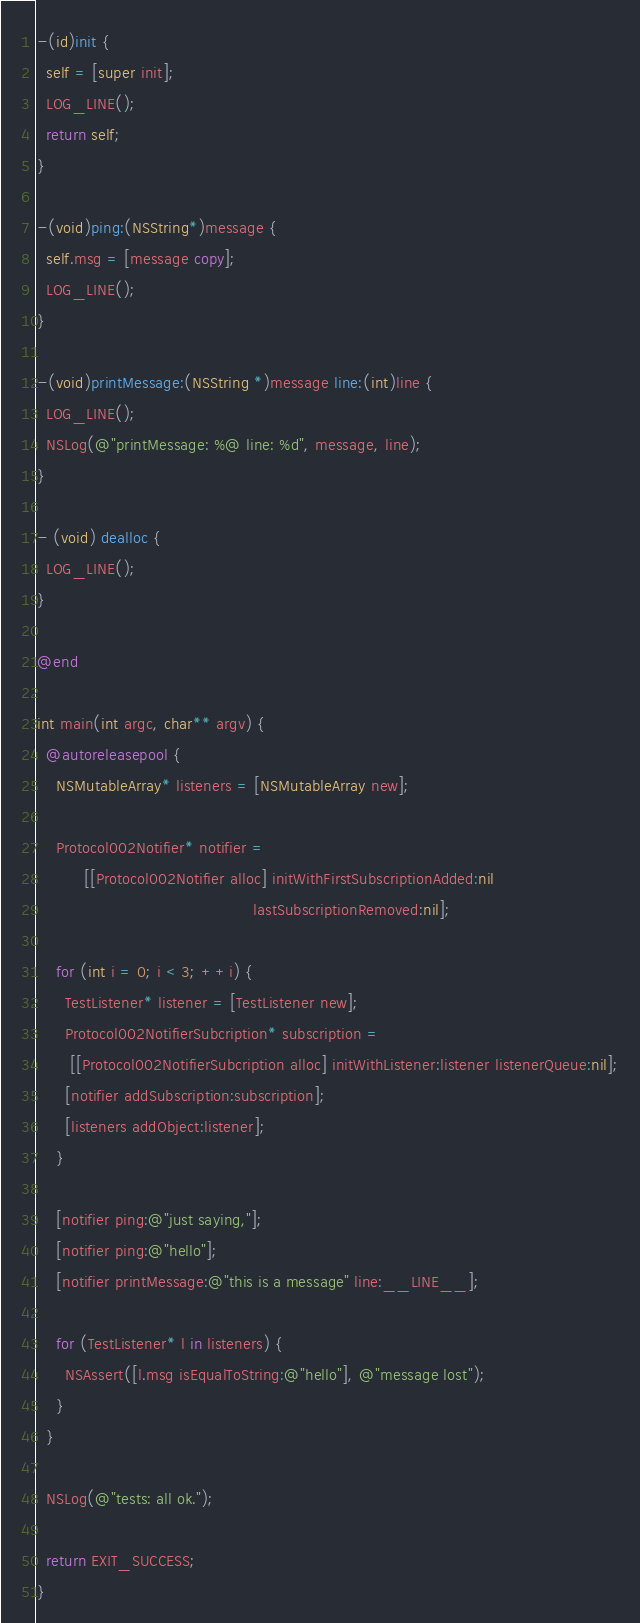Convert code to text. <code><loc_0><loc_0><loc_500><loc_500><_ObjectiveC_>
-(id)init {
  self = [super init];
  LOG_LINE();
  return self;
}

-(void)ping:(NSString*)message {
  self.msg = [message copy];
  LOG_LINE();
}

-(void)printMessage:(NSString *)message line:(int)line {
  LOG_LINE();
  NSLog(@"printMessage: %@ line: %d", message, line);
}

- (void) dealloc {
  LOG_LINE();
}

@end

int main(int argc, char** argv) {
  @autoreleasepool {
    NSMutableArray* listeners = [NSMutableArray new];

    Protocol002Notifier* notifier = 
          [[Protocol002Notifier alloc] initWithFirstSubscriptionAdded:nil
                                              lastSubscriptionRemoved:nil];

    for (int i = 0; i < 3; ++i) {
      TestListener* listener = [TestListener new];
      Protocol002NotifierSubcription* subscription = 
       [[Protocol002NotifierSubcription alloc] initWithListener:listener listenerQueue:nil];
      [notifier addSubscription:subscription];
      [listeners addObject:listener];
    }

    [notifier ping:@"just saying,"];
    [notifier ping:@"hello"];
    [notifier printMessage:@"this is a message" line:__LINE__];

    for (TestListener* l in listeners) {
      NSAssert([l.msg isEqualToString:@"hello"], @"message lost");
    }
  }

  NSLog(@"tests: all ok.");

  return EXIT_SUCCESS;
}
</code> 